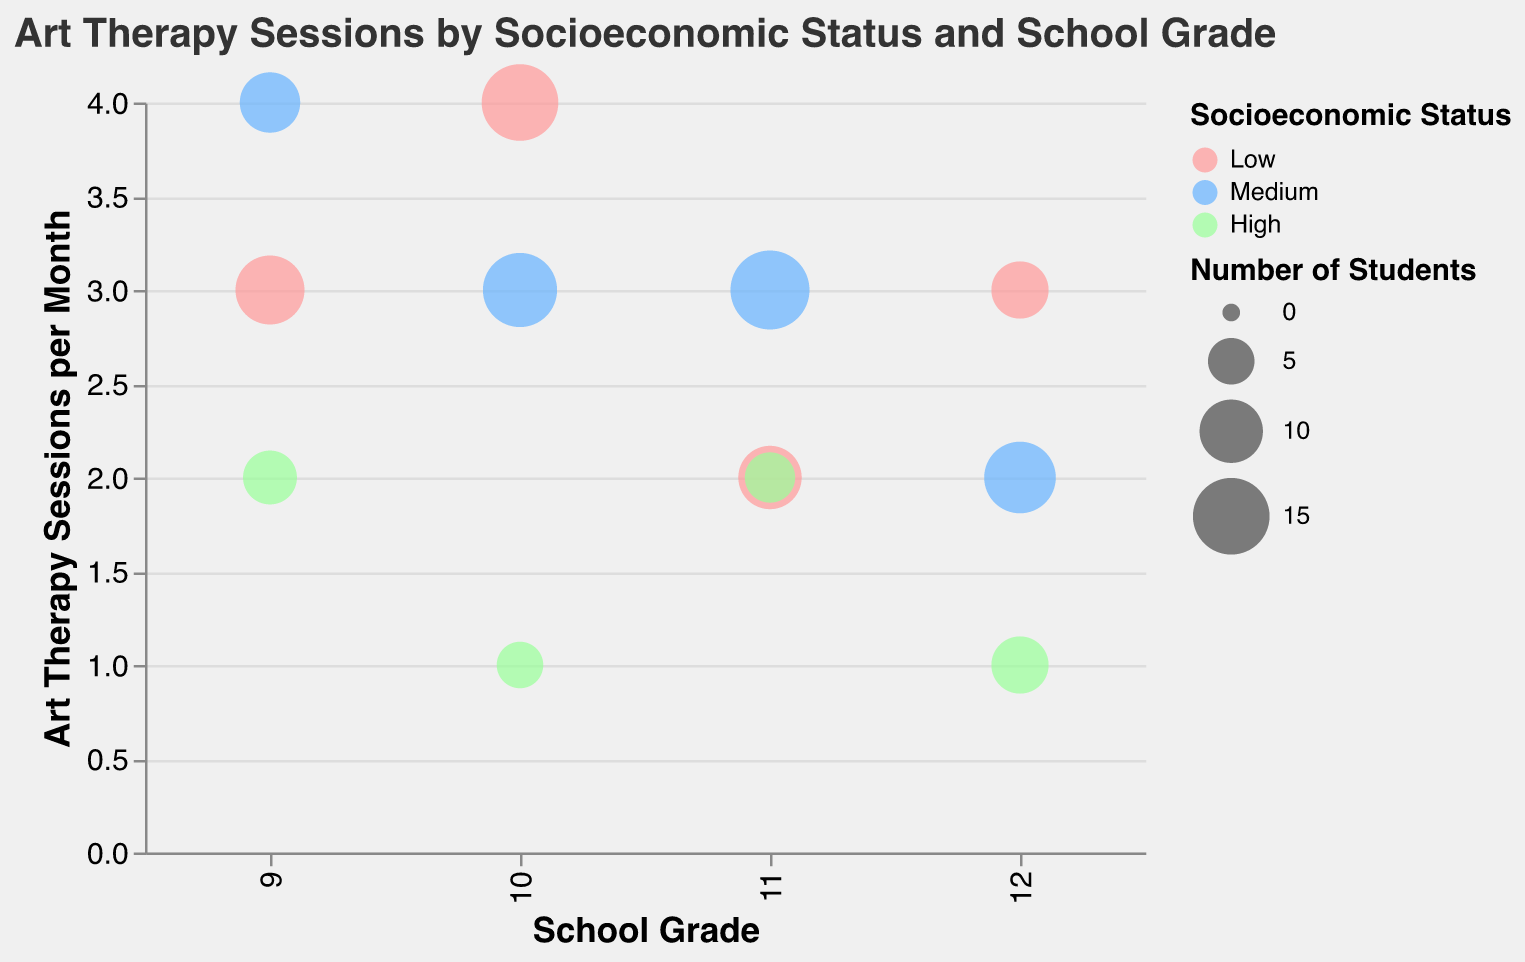What is the title of the chart? The title is displayed at the top of the chart. It reads "Art Therapy Sessions by Socioeconomic Status and School Grade".
Answer: Art Therapy Sessions by Socioeconomic Status and School Grade What socioeconomic status has the largest bubble in the 9th grade? The largest bubble in the 9th grade is indicated by its size. For the 9th grade, the largest bubble is for the Low socioeconomic status with 12 students.
Answer: Low Which socioeconomic status had the most art therapy sessions per month in the 10th grade? Looking across the 10th grade bubbles, the one with the highest position on the y-axis (Art Therapy Sessions per Month) is examined. The Low socioeconomic status had 4 sessions per month, which is the highest.
Answer: Low What is the trend of therapy sessions per month across grades for the Low socioeconomic status? Observing the y-axis values of the bubbles for Low socioeconomic status, we see the following trend: 3 sessions in 9th grade, 4 in 10th grade, 2 in 11th grade, and 3 in 12th grade. These values are neither constantly increasing nor decreasing.
Answer: Mixed trend Which school grade had the highest number of students attending art therapy sessions for the Medium socioeconomic status? The bubble size reflects the number of students. For the Medium socioeconomic status, the largest bubble corresponds to the 11th grade with 16 students.
Answer: 11th grade Compare the frequency of art therapy sessions per month for 11th graders across different socioeconomic statuses. Which status has the highest frequency? The height of the bubbles on the y-axis for 11th graders indicates the session frequency. Medium and High both have 2 sessions per month, while Low has the lowest with 2 sessions per month.
Answer: Medium and High For which grade do students from a High socioeconomic status attend therapy sessions the least? By looking at the horizontal grade classification on the x-axis and comparing the values on the y-axis (Art Therapy Sessions per Month), 10th and 12th grades have the least frequency with 1 session per month.
Answer: 10th and 12th grades What is the average number of art therapy sessions per month for all the grades in the Medium socioeconomic status? The sessions per month for Medium socioeconomic status are: 9th grade: 4, 10th grade: 3, 11th grade: 3, 12th grade: 2. The average is (4 + 3 + 3 + 2) / 4 = 3.
Answer: 3 How many socioeconomic statuses have more than 10 students attending art therapy sessions in the 11th grade? We check the bubble size for the 11th grade. For "Low" and "Medium," there are more than 10 students (10 and 16 respectively). "High" has 6 students.
Answer: 2 Is there any socioeconomic status that attends the same number of art therapy sessions per month across all grades? We compare the values on the y-axis for each socioeconomic status. No socioeconomic status attends the exact same number of sessions consistently across all grades.
Answer: No 